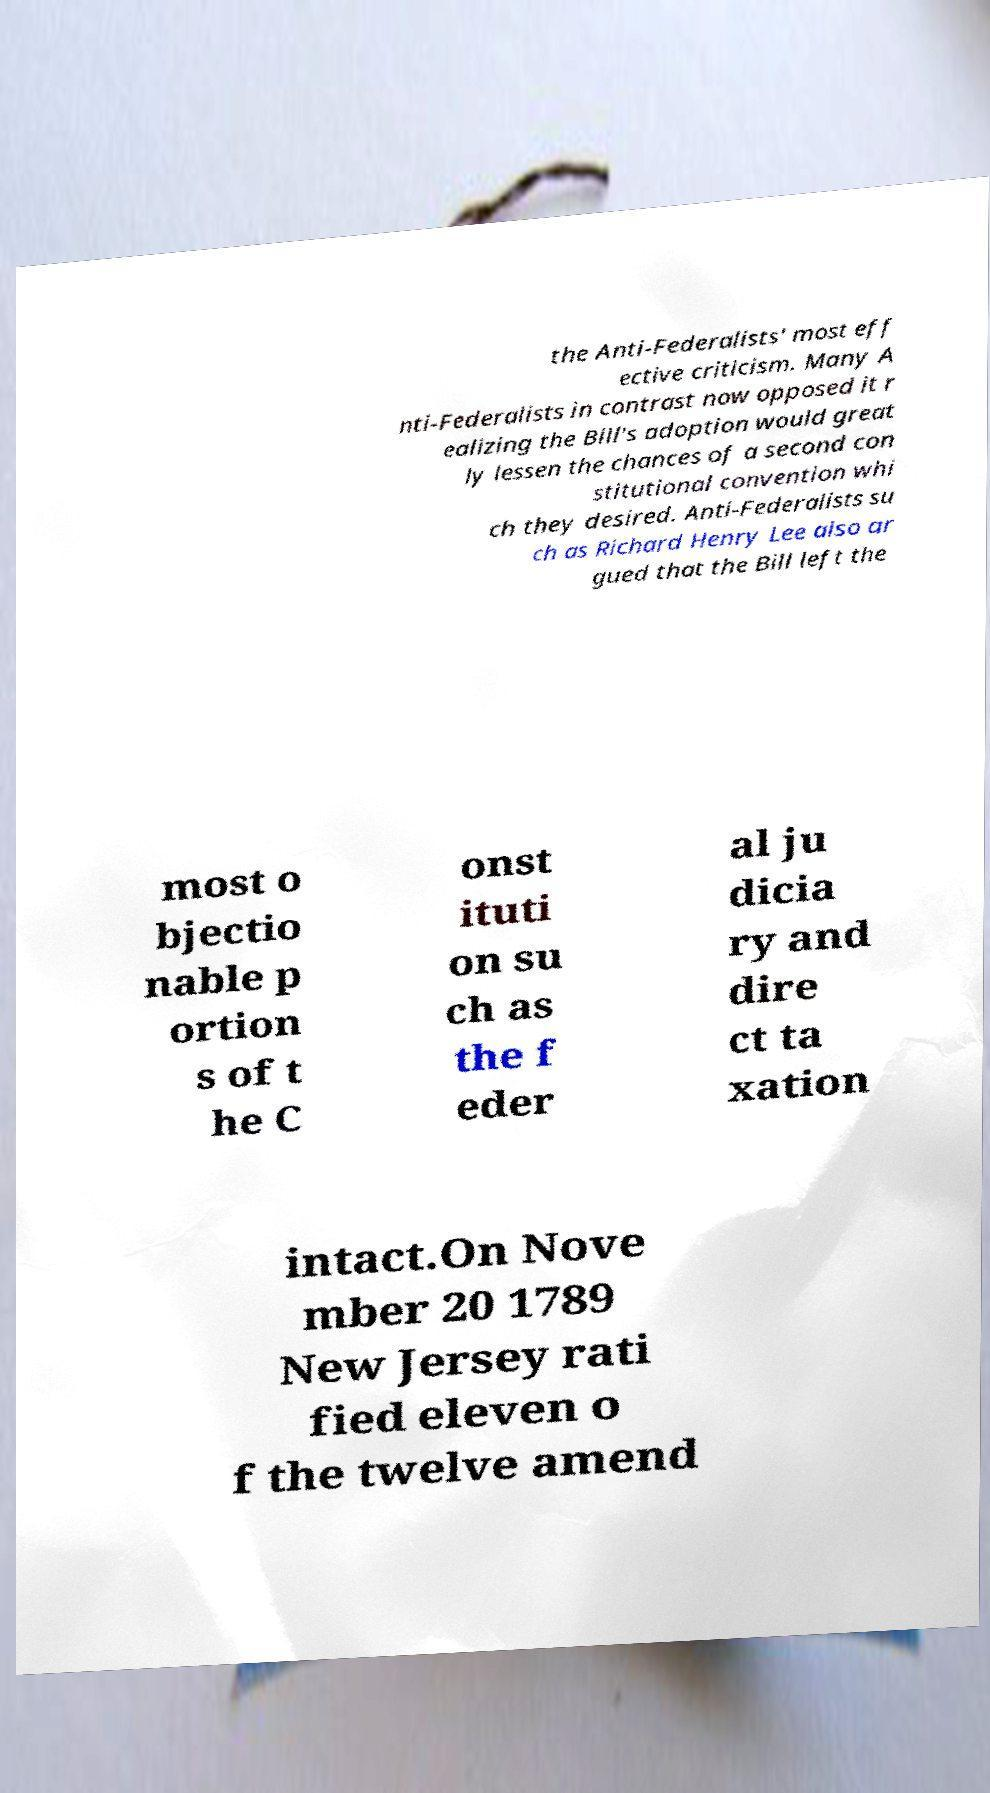Could you extract and type out the text from this image? the Anti-Federalists' most eff ective criticism. Many A nti-Federalists in contrast now opposed it r ealizing the Bill's adoption would great ly lessen the chances of a second con stitutional convention whi ch they desired. Anti-Federalists su ch as Richard Henry Lee also ar gued that the Bill left the most o bjectio nable p ortion s of t he C onst ituti on su ch as the f eder al ju dicia ry and dire ct ta xation intact.On Nove mber 20 1789 New Jersey rati fied eleven o f the twelve amend 